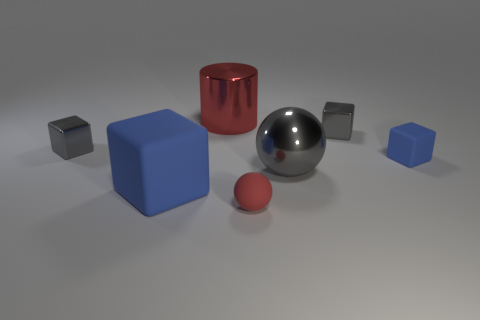There is a small shiny object that is on the right side of the large object in front of the big object to the right of the shiny cylinder; what is its shape? The small shiny object situated to the right of the larger geometric figure in front, and to the right of the glossy cylinder, is a cube. It has a reflective surface and appears to capture the ambient light, casting subtle shadows on the ground. 